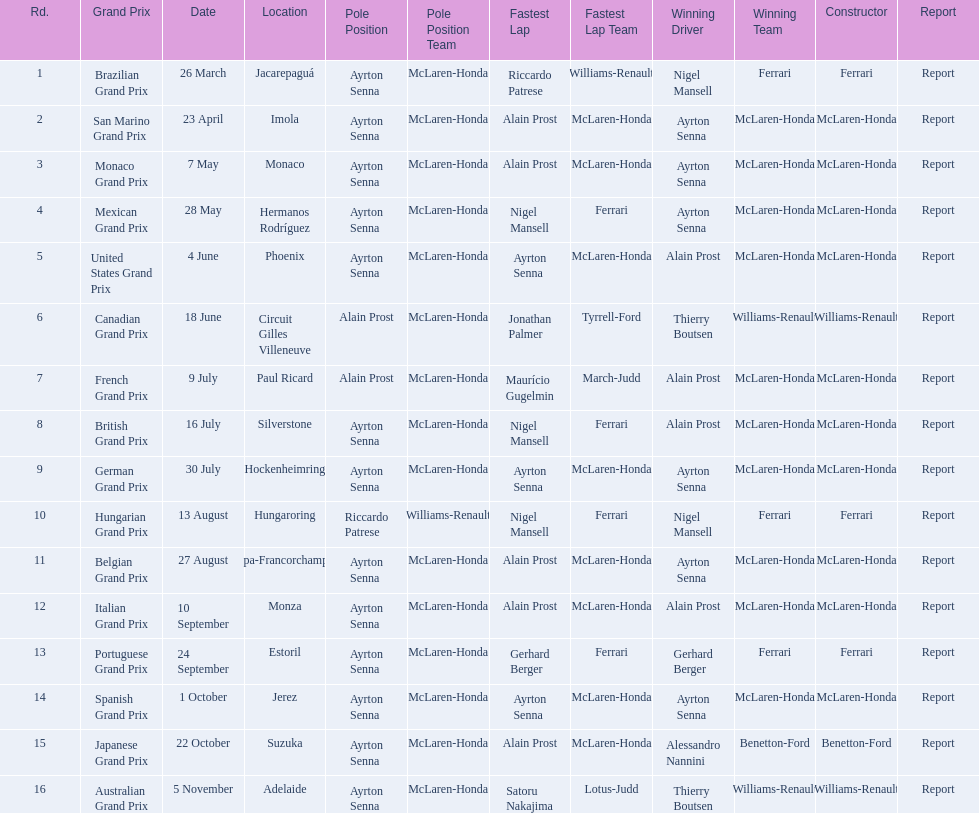What are all of the grand prix run in the 1989 formula one season? Brazilian Grand Prix, San Marino Grand Prix, Monaco Grand Prix, Mexican Grand Prix, United States Grand Prix, Canadian Grand Prix, French Grand Prix, British Grand Prix, German Grand Prix, Hungarian Grand Prix, Belgian Grand Prix, Italian Grand Prix, Portuguese Grand Prix, Spanish Grand Prix, Japanese Grand Prix, Australian Grand Prix. Of those 1989 formula one grand prix, which were run in october? Spanish Grand Prix, Japanese Grand Prix, Australian Grand Prix. Can you give me this table in json format? {'header': ['Rd.', 'Grand Prix', 'Date', 'Location', 'Pole Position', 'Pole Position Team', 'Fastest Lap', 'Fastest Lap Team', 'Winning Driver', 'Winning Team', 'Constructor', 'Report'], 'rows': [['1', 'Brazilian Grand Prix', '26 March', 'Jacarepaguá', 'Ayrton Senna', 'McLaren-Honda', 'Riccardo Patrese', 'Williams-Renault', 'Nigel Mansell', 'Ferrari', 'Ferrari', 'Report'], ['2', 'San Marino Grand Prix', '23 April', 'Imola', 'Ayrton Senna', 'McLaren-Honda', 'Alain Prost', 'McLaren-Honda', 'Ayrton Senna', 'McLaren-Honda', 'McLaren-Honda', 'Report'], ['3', 'Monaco Grand Prix', '7 May', 'Monaco', 'Ayrton Senna', 'McLaren-Honda', 'Alain Prost', 'McLaren-Honda', 'Ayrton Senna', 'McLaren-Honda', 'McLaren-Honda', 'Report'], ['4', 'Mexican Grand Prix', '28 May', 'Hermanos Rodríguez', 'Ayrton Senna', 'McLaren-Honda', 'Nigel Mansell', 'Ferrari', 'Ayrton Senna', 'McLaren-Honda', 'McLaren-Honda', 'Report'], ['5', 'United States Grand Prix', '4 June', 'Phoenix', 'Ayrton Senna', 'McLaren-Honda', 'Ayrton Senna', 'McLaren-Honda', 'Alain Prost', 'McLaren-Honda', 'McLaren-Honda', 'Report'], ['6', 'Canadian Grand Prix', '18 June', 'Circuit Gilles Villeneuve', 'Alain Prost', 'McLaren-Honda', 'Jonathan Palmer', 'Tyrrell-Ford', 'Thierry Boutsen', 'Williams-Renault', 'Williams-Renault', 'Report'], ['7', 'French Grand Prix', '9 July', 'Paul Ricard', 'Alain Prost', 'McLaren-Honda', 'Maurício Gugelmin', 'March-Judd', 'Alain Prost', 'McLaren-Honda', 'McLaren-Honda', 'Report'], ['8', 'British Grand Prix', '16 July', 'Silverstone', 'Ayrton Senna', 'McLaren-Honda', 'Nigel Mansell', 'Ferrari', 'Alain Prost', 'McLaren-Honda', 'McLaren-Honda', 'Report'], ['9', 'German Grand Prix', '30 July', 'Hockenheimring', 'Ayrton Senna', 'McLaren-Honda', 'Ayrton Senna', 'McLaren-Honda', 'Ayrton Senna', 'McLaren-Honda', 'McLaren-Honda', 'Report'], ['10', 'Hungarian Grand Prix', '13 August', 'Hungaroring', 'Riccardo Patrese', 'Williams-Renault', 'Nigel Mansell', 'Ferrari', 'Nigel Mansell', 'Ferrari', 'Ferrari', 'Report'], ['11', 'Belgian Grand Prix', '27 August', 'Spa-Francorchamps', 'Ayrton Senna', 'McLaren-Honda', 'Alain Prost', 'McLaren-Honda', 'Ayrton Senna', 'McLaren-Honda', 'McLaren-Honda', 'Report'], ['12', 'Italian Grand Prix', '10 September', 'Monza', 'Ayrton Senna', 'McLaren-Honda', 'Alain Prost', 'McLaren-Honda', 'Alain Prost', 'McLaren-Honda', 'McLaren-Honda', 'Report'], ['13', 'Portuguese Grand Prix', '24 September', 'Estoril', 'Ayrton Senna', 'McLaren-Honda', 'Gerhard Berger', 'Ferrari', 'Gerhard Berger', 'Ferrari', 'Ferrari', 'Report'], ['14', 'Spanish Grand Prix', '1 October', 'Jerez', 'Ayrton Senna', 'McLaren-Honda', 'Ayrton Senna', 'McLaren-Honda', 'Ayrton Senna', 'McLaren-Honda', 'McLaren-Honda', 'Report'], ['15', 'Japanese Grand Prix', '22 October', 'Suzuka', 'Ayrton Senna', 'McLaren-Honda', 'Alain Prost', 'McLaren-Honda', 'Alessandro Nannini', 'Benetton-Ford', 'Benetton-Ford', 'Report'], ['16', 'Australian Grand Prix', '5 November', 'Adelaide', 'Ayrton Senna', 'McLaren-Honda', 'Satoru Nakajima', 'Lotus-Judd', 'Thierry Boutsen', 'Williams-Renault', 'Williams-Renault', 'Report']]} Of those 1989 formula one grand prix run in october, which was the only one to be won by benetton-ford? Japanese Grand Prix. 